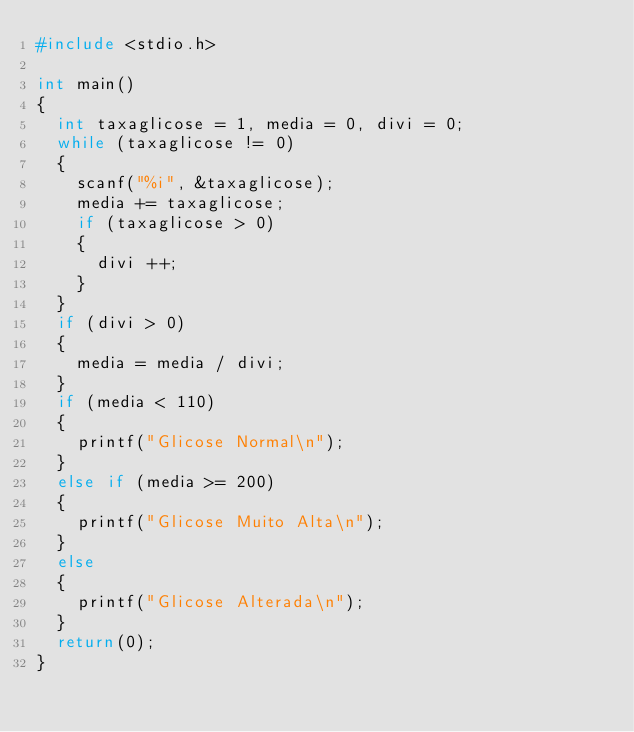Convert code to text. <code><loc_0><loc_0><loc_500><loc_500><_C_>#include <stdio.h>

int main()
{
  int taxaglicose = 1, media = 0, divi = 0;
  while (taxaglicose != 0)
  {
    scanf("%i", &taxaglicose);
    media += taxaglicose;
    if (taxaglicose > 0)
    {
      divi ++;
    }
  }
  if (divi > 0)
  {
    media = media / divi;
  }
  if (media < 110)
  {
    printf("Glicose Normal\n");
  }
  else if (media >= 200)
  {
    printf("Glicose Muito Alta\n");
  }
  else
  {
    printf("Glicose Alterada\n");
  }
  return(0);
}
</code> 